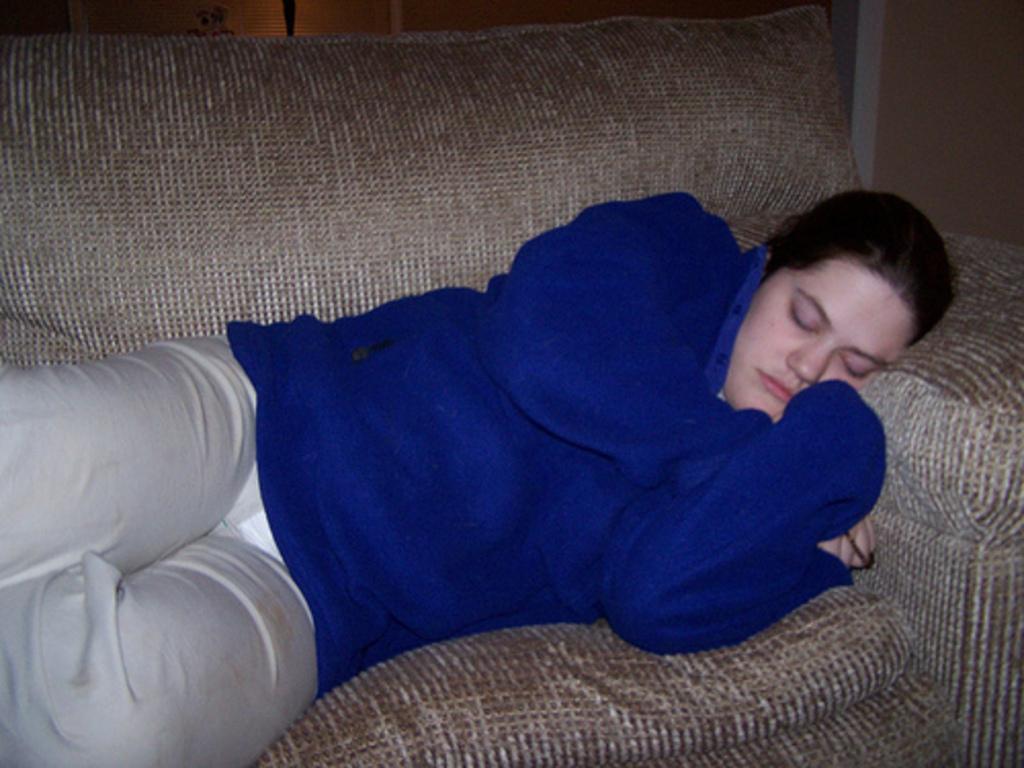Please provide a concise description of this image. In the foreground of this picture, there is a woman wearing blue coat sleeping on a couch. In the background, we can see a wall and a window blind. 